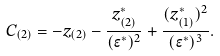Convert formula to latex. <formula><loc_0><loc_0><loc_500><loc_500>C _ { ( 2 ) } = - z _ { ( 2 ) } - \frac { z _ { ( 2 ) } ^ { * } } { ( \epsilon ^ { * } ) ^ { 2 } } + \frac { ( z _ { ( 1 ) } ^ { * } ) ^ { 2 } } { ( \epsilon ^ { * } ) ^ { 3 } } .</formula> 